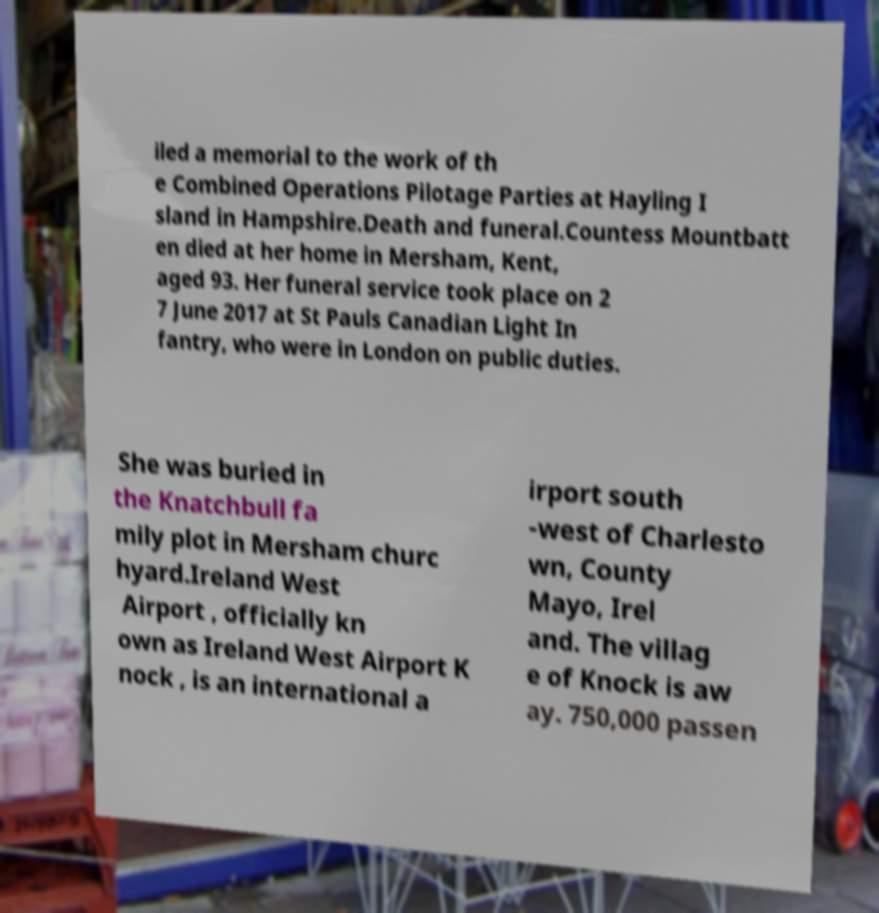Please read and relay the text visible in this image. What does it say? iled a memorial to the work of th e Combined Operations Pilotage Parties at Hayling I sland in Hampshire.Death and funeral.Countess Mountbatt en died at her home in Mersham, Kent, aged 93. Her funeral service took place on 2 7 June 2017 at St Pauls Canadian Light In fantry, who were in London on public duties. She was buried in the Knatchbull fa mily plot in Mersham churc hyard.Ireland West Airport , officially kn own as Ireland West Airport K nock , is an international a irport south -west of Charlesto wn, County Mayo, Irel and. The villag e of Knock is aw ay. 750,000 passen 